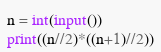<code> <loc_0><loc_0><loc_500><loc_500><_Python_>n = int(input())
print((n//2)*((n+1)//2))</code> 